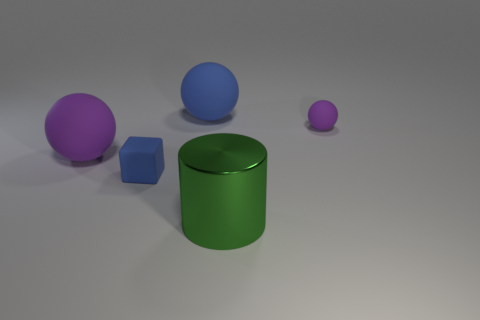Subtract all green balls. Subtract all red cubes. How many balls are left? 3 Add 2 small blue metallic balls. How many objects exist? 7 Subtract all balls. How many objects are left? 2 Add 5 balls. How many balls exist? 8 Subtract 0 gray spheres. How many objects are left? 5 Subtract all green shiny cylinders. Subtract all large matte objects. How many objects are left? 2 Add 1 purple matte objects. How many purple matte objects are left? 3 